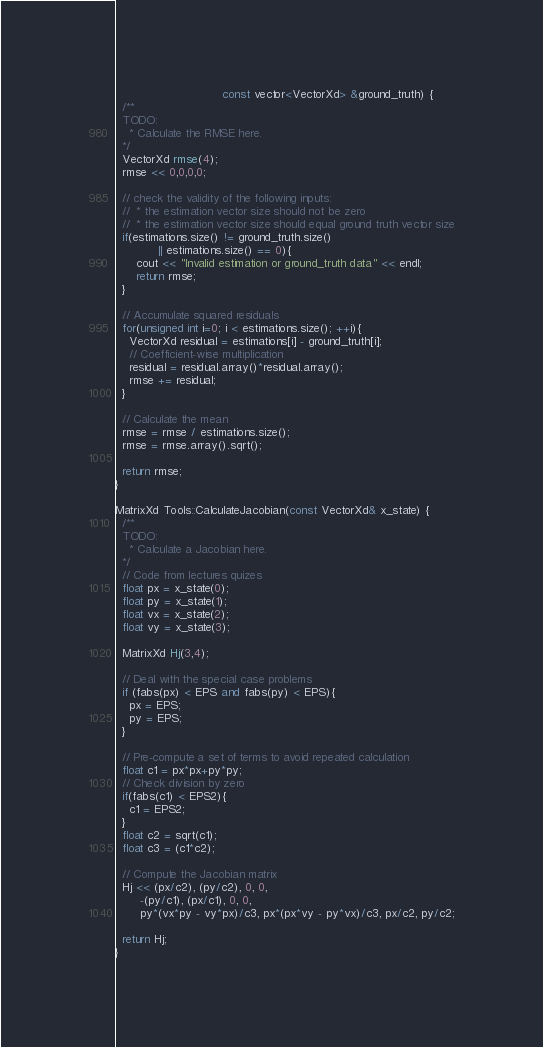Convert code to text. <code><loc_0><loc_0><loc_500><loc_500><_C++_>                              const vector<VectorXd> &ground_truth) {
  /**
  TODO:
    * Calculate the RMSE here.
  */
  VectorXd rmse(4);  
  rmse << 0,0,0,0;  
  
  // check the validity of the following inputs:
  //  * the estimation vector size should not be zero
  //  * the estimation vector size should equal ground truth vector size
  if(estimations.size() != ground_truth.size()
			|| estimations.size() == 0){
	  cout << "Invalid estimation or ground_truth data" << endl;
	  return rmse;
  }
  
  // Accumulate squared residuals
  for(unsigned int i=0; i < estimations.size(); ++i){    
  	VectorXd residual = estimations[i] - ground_truth[i];    
	// Coefficient-wise multiplication    
	residual = residual.array()*residual.array();    
	rmse += residual;  
  }
  
  // Calculate the mean  
  rmse = rmse / estimations.size();  
  rmse = rmse.array().sqrt();  

  return rmse;
}

MatrixXd Tools::CalculateJacobian(const VectorXd& x_state) {
  /**
  TODO:
    * Calculate a Jacobian here.
  */
  // Code from lectures quizes	
  float px = x_state(0);	
  float py = x_state(1);	
  float vx = x_state(2);	
  float vy = x_state(3);

  MatrixXd Hj(3,4);

  // Deal with the special case problems  
  if (fabs(px) < EPS and fabs(py) < EPS){	  
  	px = EPS;	  
	py = EPS;  
  }

  // Pre-compute a set of terms to avoid repeated calculation  
  float c1 = px*px+py*py;  
  // Check division by zero 
  if(fabs(c1) < EPS2){	
  	c1 = EPS2;  
  }  
  float c2 = sqrt(c1);  
  float c3 = (c1*c2);

  // Compute the Jacobian matrix  
  Hj << (px/c2), (py/c2), 0, 0,       
       -(py/c1), (px/c1), 0, 0,        
       py*(vx*py - vy*px)/c3, px*(px*vy - py*vx)/c3, px/c2, py/c2;
  
  return Hj;
}
</code> 